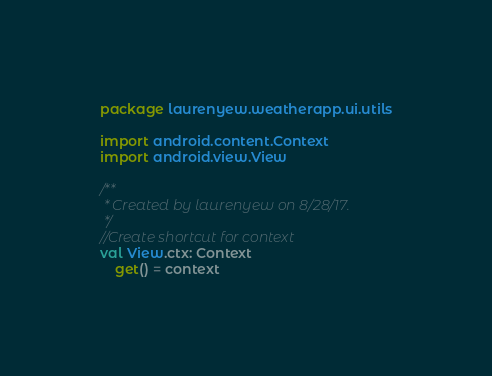Convert code to text. <code><loc_0><loc_0><loc_500><loc_500><_Kotlin_>package laurenyew.weatherapp.ui.utils

import android.content.Context
import android.view.View

/**
 * Created by laurenyew on 8/28/17.
 */
//Create shortcut for context
val View.ctx: Context
    get() = context</code> 